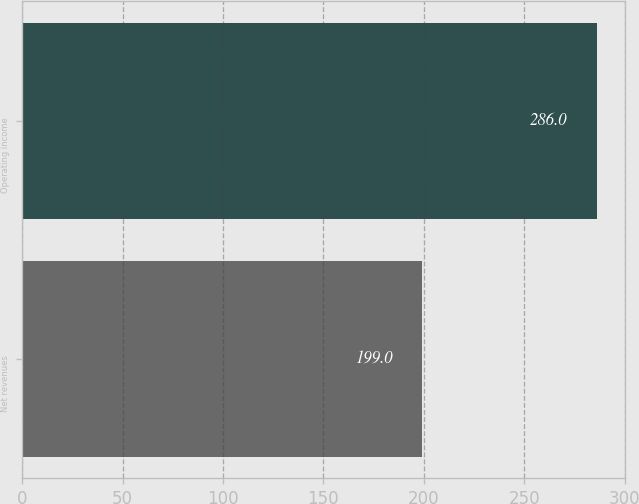<chart> <loc_0><loc_0><loc_500><loc_500><bar_chart><fcel>Net revenues<fcel>Operating income<nl><fcel>199<fcel>286<nl></chart> 